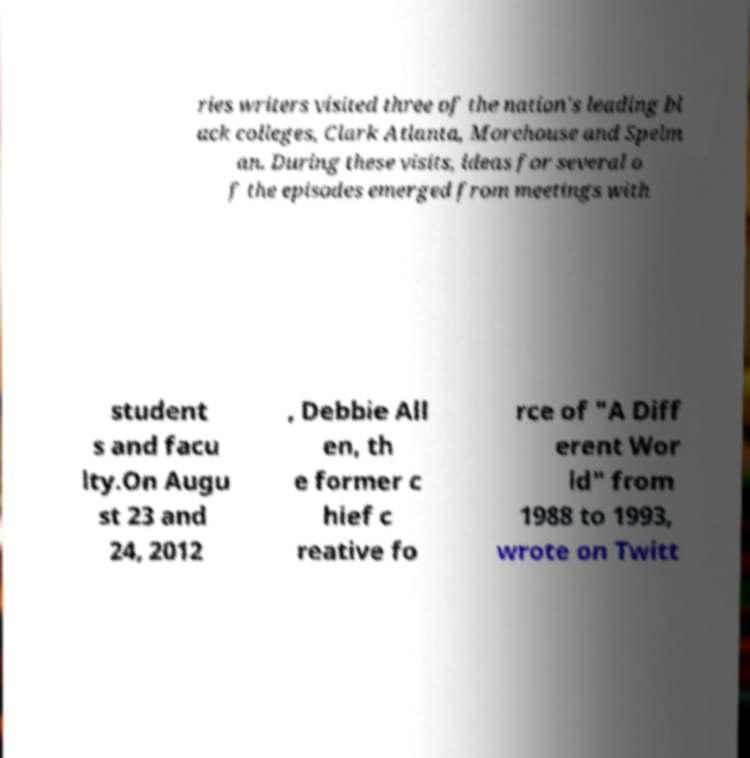There's text embedded in this image that I need extracted. Can you transcribe it verbatim? ries writers visited three of the nation's leading bl ack colleges, Clark Atlanta, Morehouse and Spelm an. During these visits, ideas for several o f the episodes emerged from meetings with student s and facu lty.On Augu st 23 and 24, 2012 , Debbie All en, th e former c hief c reative fo rce of "A Diff erent Wor ld" from 1988 to 1993, wrote on Twitt 